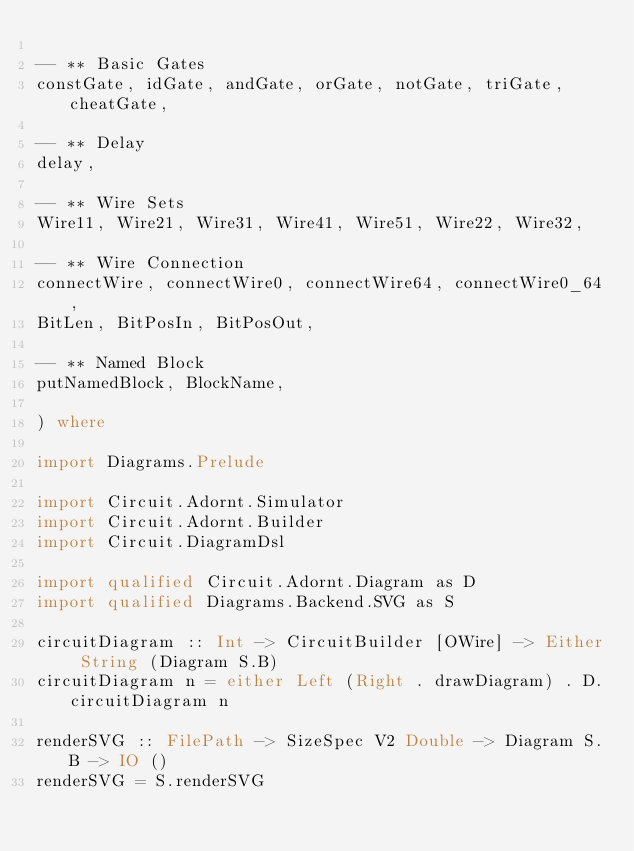Convert code to text. <code><loc_0><loc_0><loc_500><loc_500><_Haskell_>
-- ** Basic Gates
constGate, idGate, andGate, orGate, notGate, triGate, cheatGate,

-- ** Delay
delay,

-- ** Wire Sets
Wire11, Wire21, Wire31, Wire41, Wire51, Wire22, Wire32,

-- ** Wire Connection
connectWire, connectWire0, connectWire64, connectWire0_64,
BitLen, BitPosIn, BitPosOut,

-- ** Named Block
putNamedBlock, BlockName,

) where

import Diagrams.Prelude

import Circuit.Adornt.Simulator
import Circuit.Adornt.Builder
import Circuit.DiagramDsl

import qualified Circuit.Adornt.Diagram as D
import qualified Diagrams.Backend.SVG as S

circuitDiagram :: Int -> CircuitBuilder [OWire] -> Either String (Diagram S.B)
circuitDiagram n = either Left (Right . drawDiagram) . D.circuitDiagram n

renderSVG :: FilePath -> SizeSpec V2 Double -> Diagram S.B -> IO ()
renderSVG = S.renderSVG
</code> 